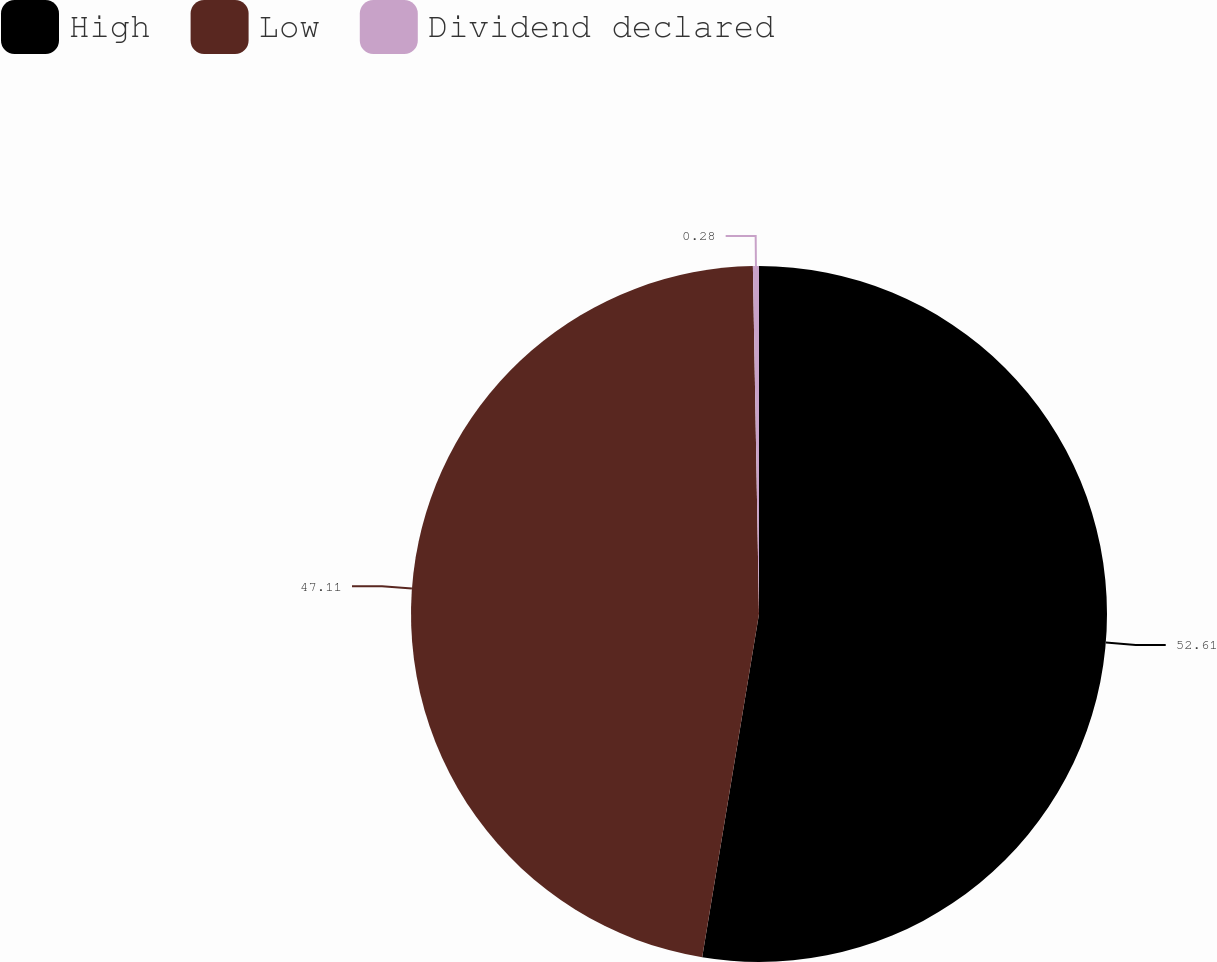Convert chart. <chart><loc_0><loc_0><loc_500><loc_500><pie_chart><fcel>High<fcel>Low<fcel>Dividend declared<nl><fcel>52.61%<fcel>47.11%<fcel>0.28%<nl></chart> 